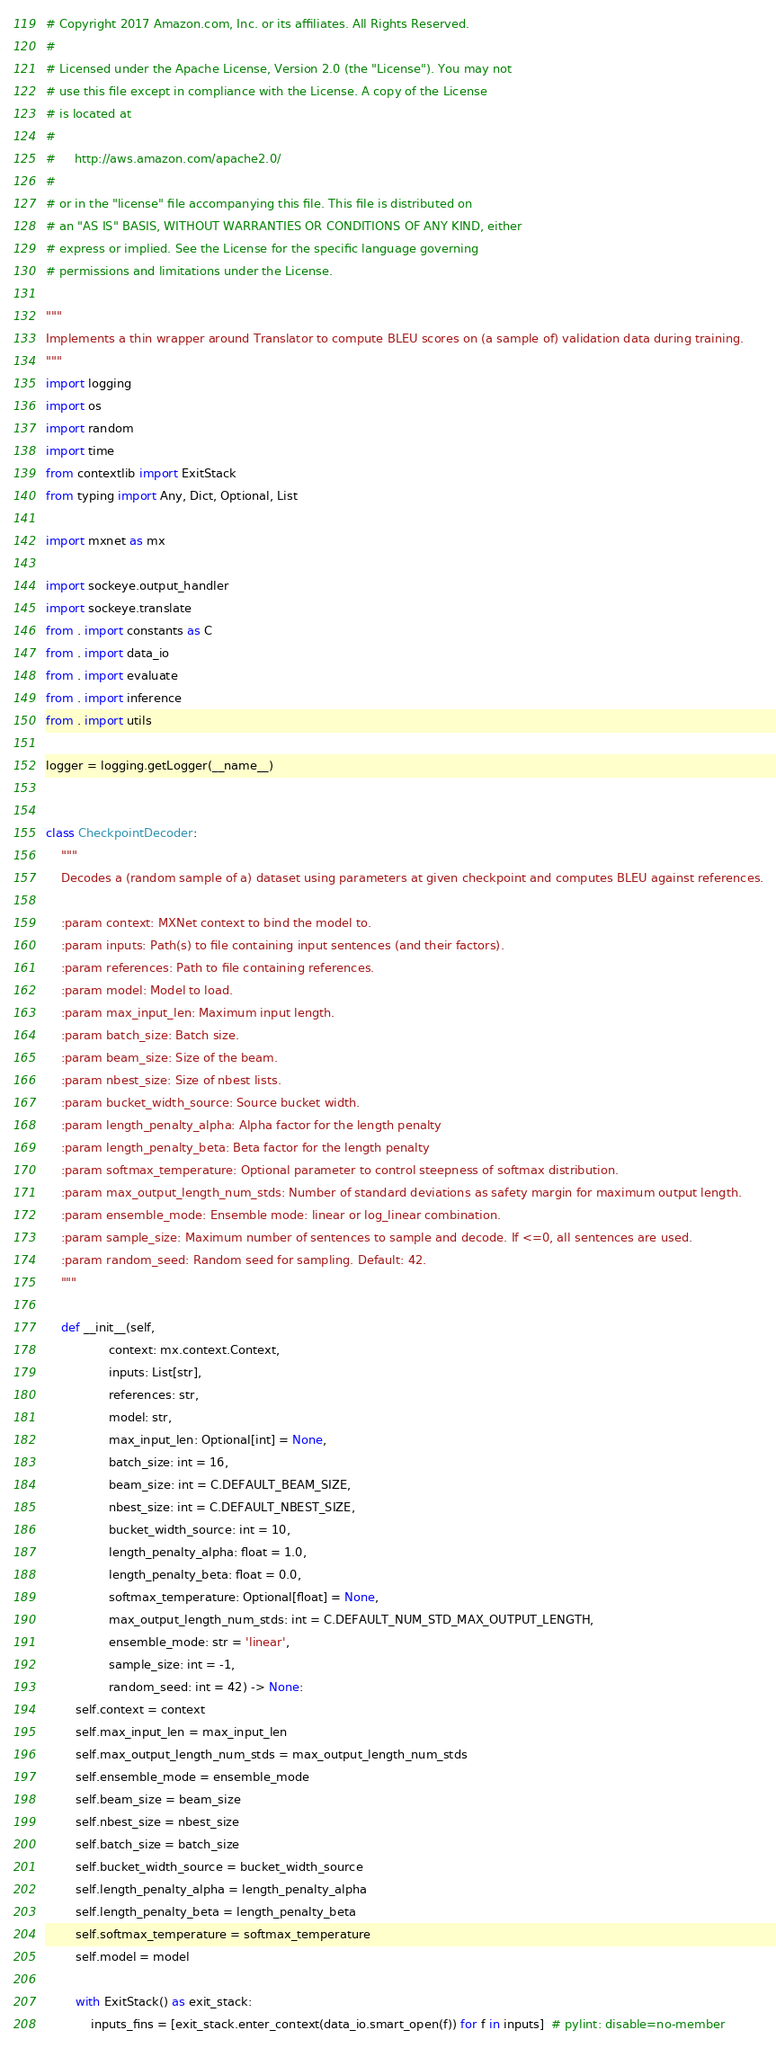<code> <loc_0><loc_0><loc_500><loc_500><_Python_># Copyright 2017 Amazon.com, Inc. or its affiliates. All Rights Reserved.
#
# Licensed under the Apache License, Version 2.0 (the "License"). You may not
# use this file except in compliance with the License. A copy of the License
# is located at
#
#     http://aws.amazon.com/apache2.0/
#
# or in the "license" file accompanying this file. This file is distributed on
# an "AS IS" BASIS, WITHOUT WARRANTIES OR CONDITIONS OF ANY KIND, either
# express or implied. See the License for the specific language governing
# permissions and limitations under the License.

"""
Implements a thin wrapper around Translator to compute BLEU scores on (a sample of) validation data during training.
"""
import logging
import os
import random
import time
from contextlib import ExitStack
from typing import Any, Dict, Optional, List

import mxnet as mx

import sockeye.output_handler
import sockeye.translate
from . import constants as C
from . import data_io
from . import evaluate
from . import inference
from . import utils

logger = logging.getLogger(__name__)


class CheckpointDecoder:
    """
    Decodes a (random sample of a) dataset using parameters at given checkpoint and computes BLEU against references.

    :param context: MXNet context to bind the model to.
    :param inputs: Path(s) to file containing input sentences (and their factors).
    :param references: Path to file containing references.
    :param model: Model to load.
    :param max_input_len: Maximum input length.
    :param batch_size: Batch size.
    :param beam_size: Size of the beam.
    :param nbest_size: Size of nbest lists.
    :param bucket_width_source: Source bucket width.
    :param length_penalty_alpha: Alpha factor for the length penalty
    :param length_penalty_beta: Beta factor for the length penalty
    :param softmax_temperature: Optional parameter to control steepness of softmax distribution.
    :param max_output_length_num_stds: Number of standard deviations as safety margin for maximum output length.
    :param ensemble_mode: Ensemble mode: linear or log_linear combination.
    :param sample_size: Maximum number of sentences to sample and decode. If <=0, all sentences are used.
    :param random_seed: Random seed for sampling. Default: 42.
    """

    def __init__(self,
                 context: mx.context.Context,
                 inputs: List[str],
                 references: str,
                 model: str,
                 max_input_len: Optional[int] = None,
                 batch_size: int = 16,
                 beam_size: int = C.DEFAULT_BEAM_SIZE,
                 nbest_size: int = C.DEFAULT_NBEST_SIZE,
                 bucket_width_source: int = 10,
                 length_penalty_alpha: float = 1.0,
                 length_penalty_beta: float = 0.0,
                 softmax_temperature: Optional[float] = None,
                 max_output_length_num_stds: int = C.DEFAULT_NUM_STD_MAX_OUTPUT_LENGTH,
                 ensemble_mode: str = 'linear',
                 sample_size: int = -1,
                 random_seed: int = 42) -> None:
        self.context = context
        self.max_input_len = max_input_len
        self.max_output_length_num_stds = max_output_length_num_stds
        self.ensemble_mode = ensemble_mode
        self.beam_size = beam_size
        self.nbest_size = nbest_size
        self.batch_size = batch_size
        self.bucket_width_source = bucket_width_source
        self.length_penalty_alpha = length_penalty_alpha
        self.length_penalty_beta = length_penalty_beta
        self.softmax_temperature = softmax_temperature
        self.model = model

        with ExitStack() as exit_stack:
            inputs_fins = [exit_stack.enter_context(data_io.smart_open(f)) for f in inputs]  # pylint: disable=no-member</code> 